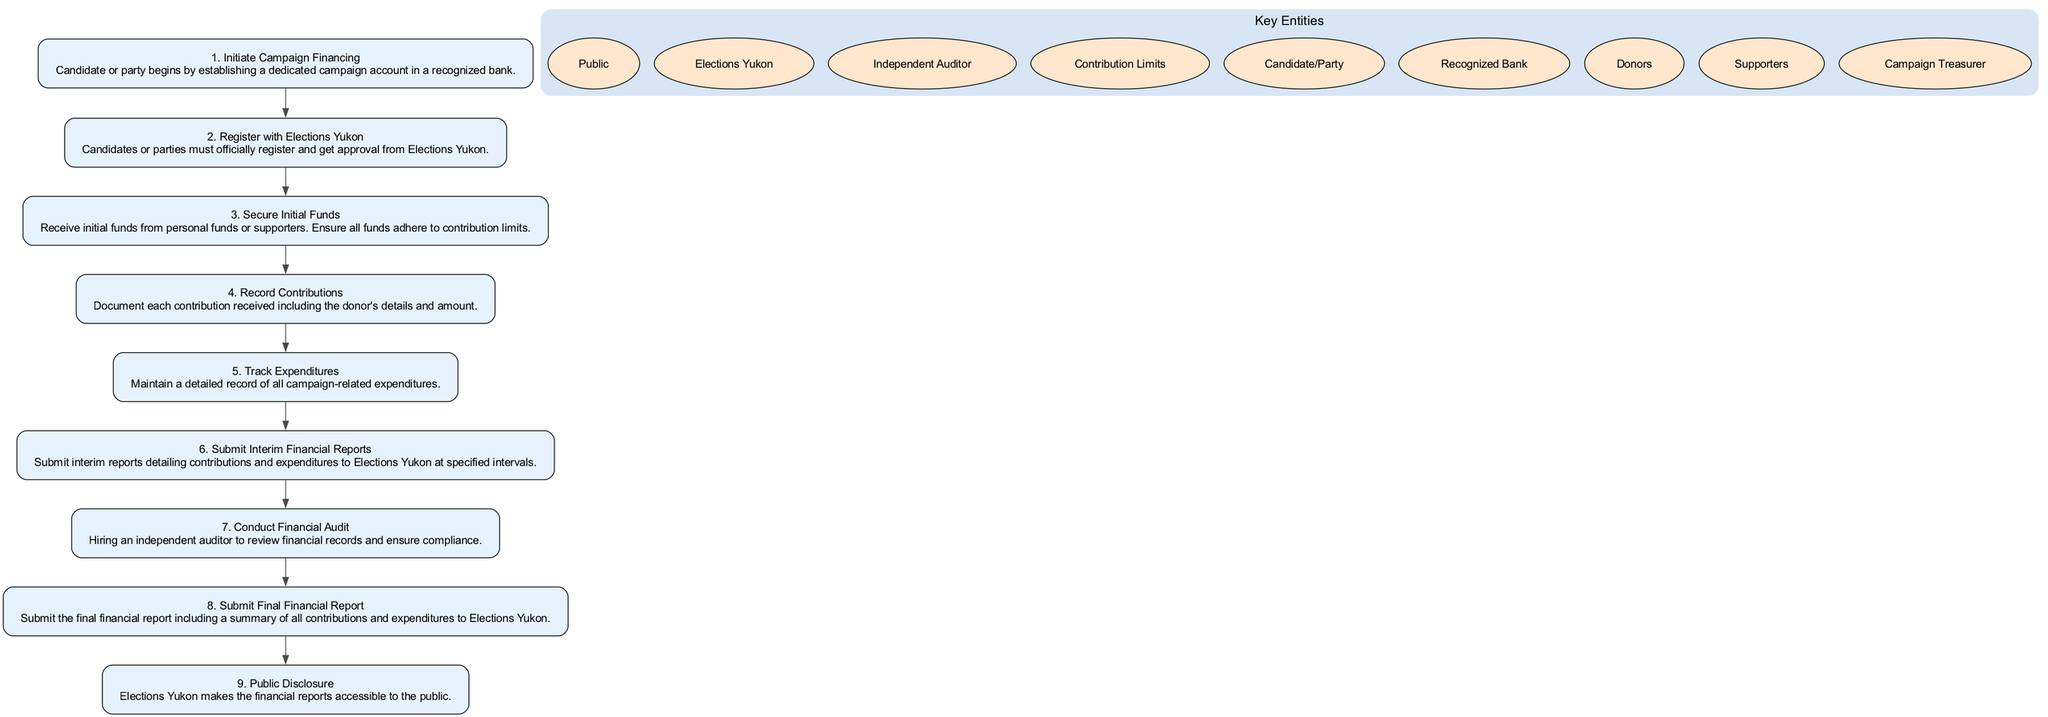What is the first step in the process? The first step is labeled "1. Initiate Campaign Financing" which prompts the candidate or party to establish a campaign account in a recognized bank.
Answer: Initiate Campaign Financing How many steps are in the process? Counting all the nodes in the diagram, there are nine distinct steps outlined in the process of campaign financing and expenditure disclosure.
Answer: 9 What must be done after securing initial funds? Following the step of securing initial funds, the next step is to "Record Contributions", where the candidate or party documents contributions received from donors.
Answer: Record Contributions Who must candidates or parties register with? Candidates or parties are required to register with "Elections Yukon" to gain approval to proceed with their campaign.
Answer: Elections Yukon What happens to the financial reports after submission? After the final financial report is submitted, "Elections Yukon" will make the financial reports accessible to the public, ensuring transparency in campaign financing.
Answer: Public Disclosure What role does the Campaign Treasurer play? The Campaign Treasurer is involved in multiple steps, specifically in recording contributions, tracking expenditures, and submitting interim and final financial reports.
Answer: Multiple roles What is the purpose of the financial audit? The financial audit ensures compliance with campaign financing regulations by involving an independent auditor to review the financial records.
Answer: Compliance Which step requires timing for report submission? The step that requires specific timing for submission of reports is "Submit Interim Financial Reports," where candidates or parties must report contributions and expenditures at predetermined intervals.
Answer: Submit Interim Financial Reports Identify the last step of the process. The last step in the campaign financing process is "9. Public Disclosure," which indicates that the reports are made available to the public after all submissions are completed.
Answer: Public Disclosure 